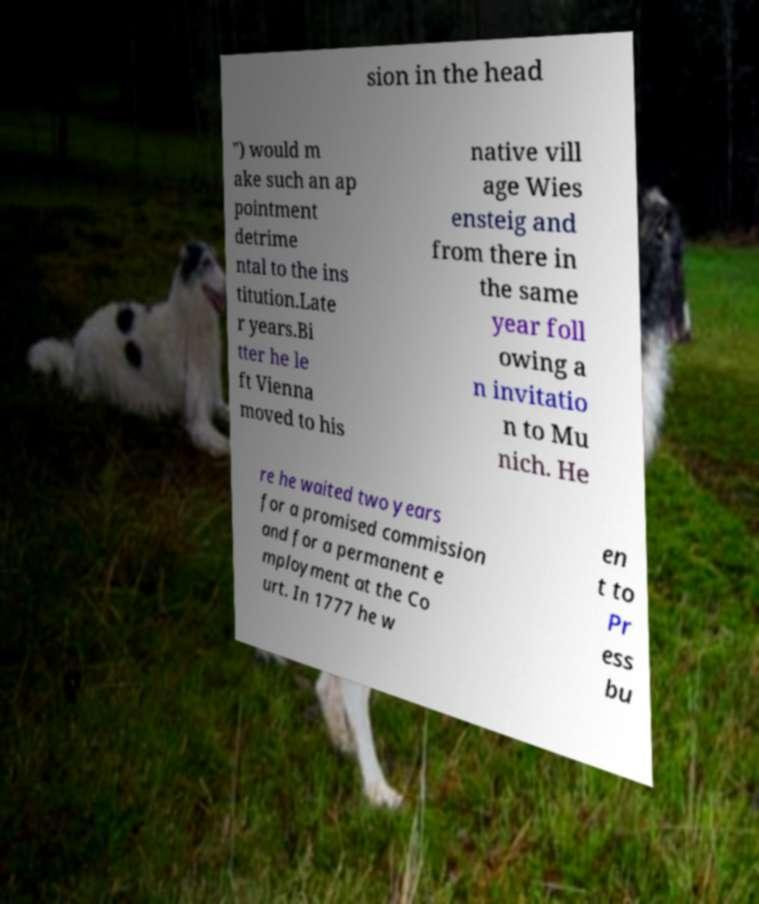Can you read and provide the text displayed in the image?This photo seems to have some interesting text. Can you extract and type it out for me? sion in the head ") would m ake such an ap pointment detrime ntal to the ins titution.Late r years.Bi tter he le ft Vienna moved to his native vill age Wies ensteig and from there in the same year foll owing a n invitatio n to Mu nich. He re he waited two years for a promised commission and for a permanent e mployment at the Co urt. In 1777 he w en t to Pr ess bu 